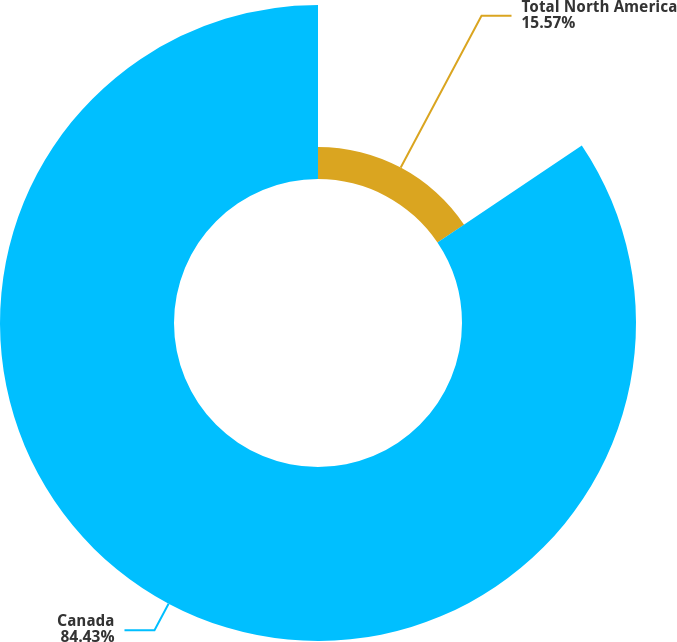<chart> <loc_0><loc_0><loc_500><loc_500><pie_chart><fcel>Total North America<fcel>Canada<nl><fcel>15.57%<fcel>84.43%<nl></chart> 